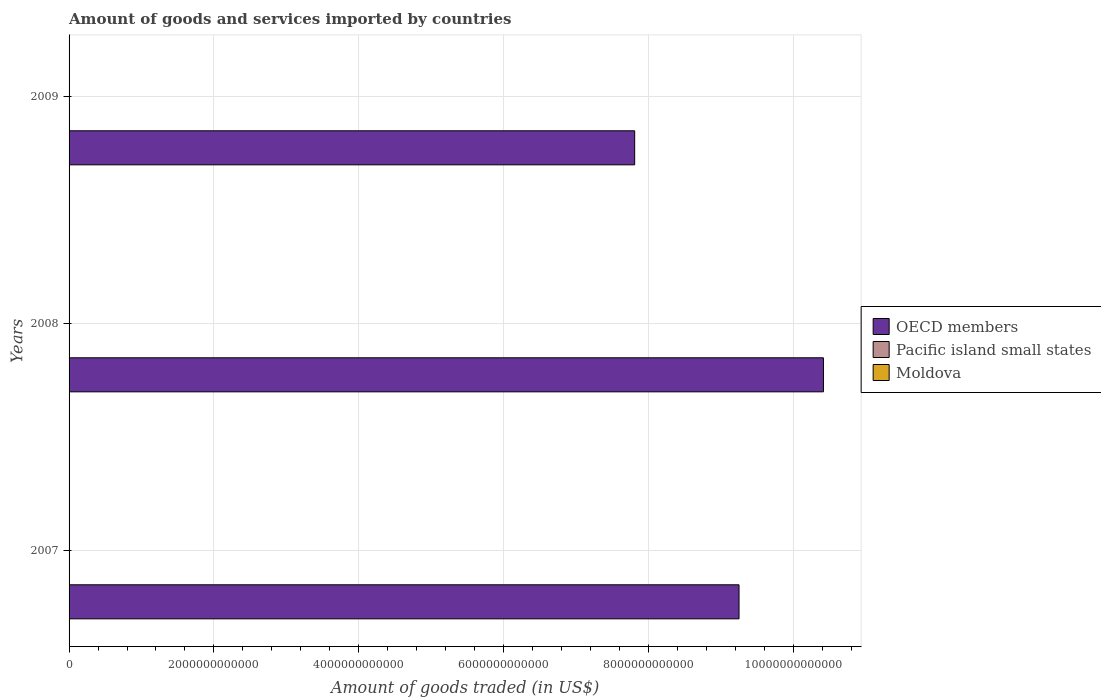How many different coloured bars are there?
Offer a very short reply. 3. How many groups of bars are there?
Your response must be concise. 3. Are the number of bars on each tick of the Y-axis equal?
Your answer should be compact. Yes. What is the total amount of goods and services imported in Moldova in 2008?
Make the answer very short. 4.53e+09. Across all years, what is the maximum total amount of goods and services imported in Pacific island small states?
Provide a short and direct response. 3.49e+09. Across all years, what is the minimum total amount of goods and services imported in OECD members?
Your response must be concise. 7.81e+12. In which year was the total amount of goods and services imported in Pacific island small states minimum?
Keep it short and to the point. 2009. What is the total total amount of goods and services imported in Pacific island small states in the graph?
Keep it short and to the point. 8.75e+09. What is the difference between the total amount of goods and services imported in Moldova in 2008 and that in 2009?
Provide a succinct answer. 1.54e+09. What is the difference between the total amount of goods and services imported in Moldova in 2008 and the total amount of goods and services imported in OECD members in 2007?
Offer a terse response. -9.25e+12. What is the average total amount of goods and services imported in OECD members per year?
Offer a terse response. 9.16e+12. In the year 2008, what is the difference between the total amount of goods and services imported in Pacific island small states and total amount of goods and services imported in Moldova?
Your answer should be compact. -1.04e+09. In how many years, is the total amount of goods and services imported in Pacific island small states greater than 6400000000000 US$?
Make the answer very short. 0. What is the ratio of the total amount of goods and services imported in OECD members in 2007 to that in 2009?
Give a very brief answer. 1.18. Is the total amount of goods and services imported in Pacific island small states in 2007 less than that in 2008?
Provide a short and direct response. Yes. Is the difference between the total amount of goods and services imported in Pacific island small states in 2007 and 2008 greater than the difference between the total amount of goods and services imported in Moldova in 2007 and 2008?
Keep it short and to the point. Yes. What is the difference between the highest and the second highest total amount of goods and services imported in OECD members?
Provide a succinct answer. 1.17e+12. What is the difference between the highest and the lowest total amount of goods and services imported in Moldova?
Provide a succinct answer. 1.54e+09. In how many years, is the total amount of goods and services imported in OECD members greater than the average total amount of goods and services imported in OECD members taken over all years?
Your answer should be compact. 2. Is the sum of the total amount of goods and services imported in OECD members in 2008 and 2009 greater than the maximum total amount of goods and services imported in Moldova across all years?
Provide a succinct answer. Yes. What does the 2nd bar from the top in 2009 represents?
Provide a succinct answer. Pacific island small states. What does the 3rd bar from the bottom in 2007 represents?
Make the answer very short. Moldova. Is it the case that in every year, the sum of the total amount of goods and services imported in OECD members and total amount of goods and services imported in Pacific island small states is greater than the total amount of goods and services imported in Moldova?
Your answer should be very brief. Yes. How many years are there in the graph?
Your response must be concise. 3. What is the difference between two consecutive major ticks on the X-axis?
Your answer should be compact. 2.00e+12. Does the graph contain grids?
Your answer should be very brief. Yes. Where does the legend appear in the graph?
Make the answer very short. Center right. What is the title of the graph?
Your answer should be compact. Amount of goods and services imported by countries. What is the label or title of the X-axis?
Give a very brief answer. Amount of goods traded (in US$). What is the Amount of goods traded (in US$) of OECD members in 2007?
Your response must be concise. 9.25e+12. What is the Amount of goods traded (in US$) in Pacific island small states in 2007?
Your answer should be compact. 2.80e+09. What is the Amount of goods traded (in US$) of Moldova in 2007?
Your answer should be very brief. 3.41e+09. What is the Amount of goods traded (in US$) in OECD members in 2008?
Offer a terse response. 1.04e+13. What is the Amount of goods traded (in US$) in Pacific island small states in 2008?
Your answer should be compact. 3.49e+09. What is the Amount of goods traded (in US$) in Moldova in 2008?
Provide a succinct answer. 4.53e+09. What is the Amount of goods traded (in US$) of OECD members in 2009?
Provide a short and direct response. 7.81e+12. What is the Amount of goods traded (in US$) of Pacific island small states in 2009?
Provide a short and direct response. 2.46e+09. What is the Amount of goods traded (in US$) of Moldova in 2009?
Offer a terse response. 2.99e+09. Across all years, what is the maximum Amount of goods traded (in US$) in OECD members?
Provide a short and direct response. 1.04e+13. Across all years, what is the maximum Amount of goods traded (in US$) in Pacific island small states?
Your answer should be very brief. 3.49e+09. Across all years, what is the maximum Amount of goods traded (in US$) in Moldova?
Provide a short and direct response. 4.53e+09. Across all years, what is the minimum Amount of goods traded (in US$) of OECD members?
Ensure brevity in your answer.  7.81e+12. Across all years, what is the minimum Amount of goods traded (in US$) of Pacific island small states?
Provide a succinct answer. 2.46e+09. Across all years, what is the minimum Amount of goods traded (in US$) in Moldova?
Offer a very short reply. 2.99e+09. What is the total Amount of goods traded (in US$) in OECD members in the graph?
Provide a succinct answer. 2.75e+13. What is the total Amount of goods traded (in US$) in Pacific island small states in the graph?
Your answer should be very brief. 8.75e+09. What is the total Amount of goods traded (in US$) of Moldova in the graph?
Your answer should be very brief. 1.09e+1. What is the difference between the Amount of goods traded (in US$) in OECD members in 2007 and that in 2008?
Make the answer very short. -1.17e+12. What is the difference between the Amount of goods traded (in US$) of Pacific island small states in 2007 and that in 2008?
Provide a succinct answer. -6.88e+08. What is the difference between the Amount of goods traded (in US$) of Moldova in 2007 and that in 2008?
Your response must be concise. -1.12e+09. What is the difference between the Amount of goods traded (in US$) in OECD members in 2007 and that in 2009?
Your answer should be compact. 1.44e+12. What is the difference between the Amount of goods traded (in US$) in Pacific island small states in 2007 and that in 2009?
Your answer should be very brief. 3.37e+08. What is the difference between the Amount of goods traded (in US$) in Moldova in 2007 and that in 2009?
Your answer should be compact. 4.22e+08. What is the difference between the Amount of goods traded (in US$) in OECD members in 2008 and that in 2009?
Your answer should be very brief. 2.61e+12. What is the difference between the Amount of goods traded (in US$) in Pacific island small states in 2008 and that in 2009?
Your answer should be compact. 1.02e+09. What is the difference between the Amount of goods traded (in US$) in Moldova in 2008 and that in 2009?
Keep it short and to the point. 1.54e+09. What is the difference between the Amount of goods traded (in US$) of OECD members in 2007 and the Amount of goods traded (in US$) of Pacific island small states in 2008?
Provide a succinct answer. 9.25e+12. What is the difference between the Amount of goods traded (in US$) in OECD members in 2007 and the Amount of goods traded (in US$) in Moldova in 2008?
Give a very brief answer. 9.25e+12. What is the difference between the Amount of goods traded (in US$) of Pacific island small states in 2007 and the Amount of goods traded (in US$) of Moldova in 2008?
Provide a succinct answer. -1.73e+09. What is the difference between the Amount of goods traded (in US$) in OECD members in 2007 and the Amount of goods traded (in US$) in Pacific island small states in 2009?
Offer a terse response. 9.25e+12. What is the difference between the Amount of goods traded (in US$) in OECD members in 2007 and the Amount of goods traded (in US$) in Moldova in 2009?
Your answer should be compact. 9.25e+12. What is the difference between the Amount of goods traded (in US$) in Pacific island small states in 2007 and the Amount of goods traded (in US$) in Moldova in 2009?
Ensure brevity in your answer.  -1.86e+08. What is the difference between the Amount of goods traded (in US$) in OECD members in 2008 and the Amount of goods traded (in US$) in Pacific island small states in 2009?
Your answer should be very brief. 1.04e+13. What is the difference between the Amount of goods traded (in US$) of OECD members in 2008 and the Amount of goods traded (in US$) of Moldova in 2009?
Your answer should be compact. 1.04e+13. What is the difference between the Amount of goods traded (in US$) of Pacific island small states in 2008 and the Amount of goods traded (in US$) of Moldova in 2009?
Your answer should be very brief. 5.02e+08. What is the average Amount of goods traded (in US$) of OECD members per year?
Ensure brevity in your answer.  9.16e+12. What is the average Amount of goods traded (in US$) in Pacific island small states per year?
Your answer should be very brief. 2.92e+09. What is the average Amount of goods traded (in US$) in Moldova per year?
Give a very brief answer. 3.64e+09. In the year 2007, what is the difference between the Amount of goods traded (in US$) in OECD members and Amount of goods traded (in US$) in Pacific island small states?
Offer a very short reply. 9.25e+12. In the year 2007, what is the difference between the Amount of goods traded (in US$) in OECD members and Amount of goods traded (in US$) in Moldova?
Keep it short and to the point. 9.25e+12. In the year 2007, what is the difference between the Amount of goods traded (in US$) in Pacific island small states and Amount of goods traded (in US$) in Moldova?
Your answer should be very brief. -6.08e+08. In the year 2008, what is the difference between the Amount of goods traded (in US$) of OECD members and Amount of goods traded (in US$) of Pacific island small states?
Your response must be concise. 1.04e+13. In the year 2008, what is the difference between the Amount of goods traded (in US$) in OECD members and Amount of goods traded (in US$) in Moldova?
Your response must be concise. 1.04e+13. In the year 2008, what is the difference between the Amount of goods traded (in US$) in Pacific island small states and Amount of goods traded (in US$) in Moldova?
Your response must be concise. -1.04e+09. In the year 2009, what is the difference between the Amount of goods traded (in US$) of OECD members and Amount of goods traded (in US$) of Pacific island small states?
Keep it short and to the point. 7.81e+12. In the year 2009, what is the difference between the Amount of goods traded (in US$) of OECD members and Amount of goods traded (in US$) of Moldova?
Offer a terse response. 7.81e+12. In the year 2009, what is the difference between the Amount of goods traded (in US$) in Pacific island small states and Amount of goods traded (in US$) in Moldova?
Provide a succinct answer. -5.22e+08. What is the ratio of the Amount of goods traded (in US$) in OECD members in 2007 to that in 2008?
Ensure brevity in your answer.  0.89. What is the ratio of the Amount of goods traded (in US$) in Pacific island small states in 2007 to that in 2008?
Keep it short and to the point. 0.8. What is the ratio of the Amount of goods traded (in US$) of Moldova in 2007 to that in 2008?
Offer a terse response. 0.75. What is the ratio of the Amount of goods traded (in US$) in OECD members in 2007 to that in 2009?
Provide a succinct answer. 1.18. What is the ratio of the Amount of goods traded (in US$) in Pacific island small states in 2007 to that in 2009?
Offer a terse response. 1.14. What is the ratio of the Amount of goods traded (in US$) of Moldova in 2007 to that in 2009?
Your answer should be very brief. 1.14. What is the ratio of the Amount of goods traded (in US$) in OECD members in 2008 to that in 2009?
Provide a succinct answer. 1.33. What is the ratio of the Amount of goods traded (in US$) in Pacific island small states in 2008 to that in 2009?
Provide a short and direct response. 1.42. What is the ratio of the Amount of goods traded (in US$) of Moldova in 2008 to that in 2009?
Give a very brief answer. 1.52. What is the difference between the highest and the second highest Amount of goods traded (in US$) of OECD members?
Offer a terse response. 1.17e+12. What is the difference between the highest and the second highest Amount of goods traded (in US$) of Pacific island small states?
Your response must be concise. 6.88e+08. What is the difference between the highest and the second highest Amount of goods traded (in US$) in Moldova?
Make the answer very short. 1.12e+09. What is the difference between the highest and the lowest Amount of goods traded (in US$) of OECD members?
Your response must be concise. 2.61e+12. What is the difference between the highest and the lowest Amount of goods traded (in US$) of Pacific island small states?
Offer a terse response. 1.02e+09. What is the difference between the highest and the lowest Amount of goods traded (in US$) in Moldova?
Ensure brevity in your answer.  1.54e+09. 